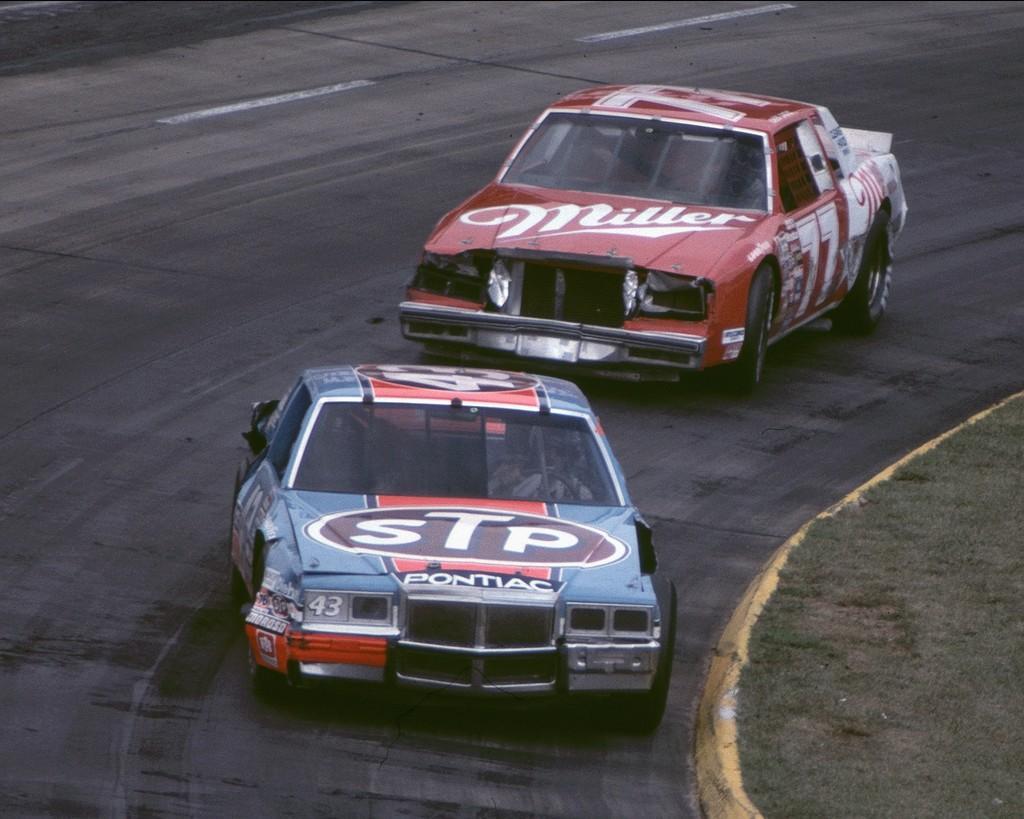Describe this image in one or two sentences. In this image there are two cars one behind the other On the road. On the footpath there is grass. 